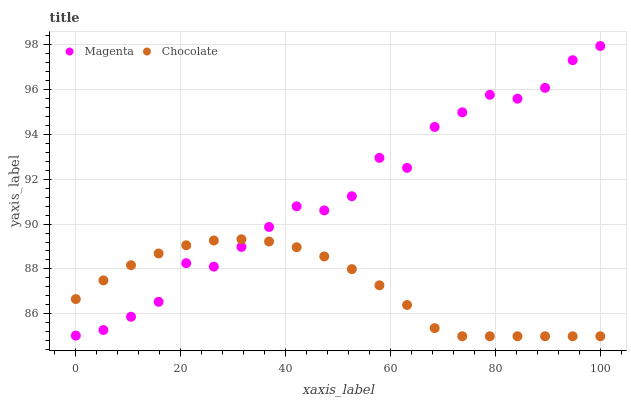Does Chocolate have the minimum area under the curve?
Answer yes or no. Yes. Does Magenta have the maximum area under the curve?
Answer yes or no. Yes. Does Chocolate have the maximum area under the curve?
Answer yes or no. No. Is Chocolate the smoothest?
Answer yes or no. Yes. Is Magenta the roughest?
Answer yes or no. Yes. Is Chocolate the roughest?
Answer yes or no. No. Does Chocolate have the lowest value?
Answer yes or no. Yes. Does Magenta have the highest value?
Answer yes or no. Yes. Does Chocolate have the highest value?
Answer yes or no. No. Does Magenta intersect Chocolate?
Answer yes or no. Yes. Is Magenta less than Chocolate?
Answer yes or no. No. Is Magenta greater than Chocolate?
Answer yes or no. No. 